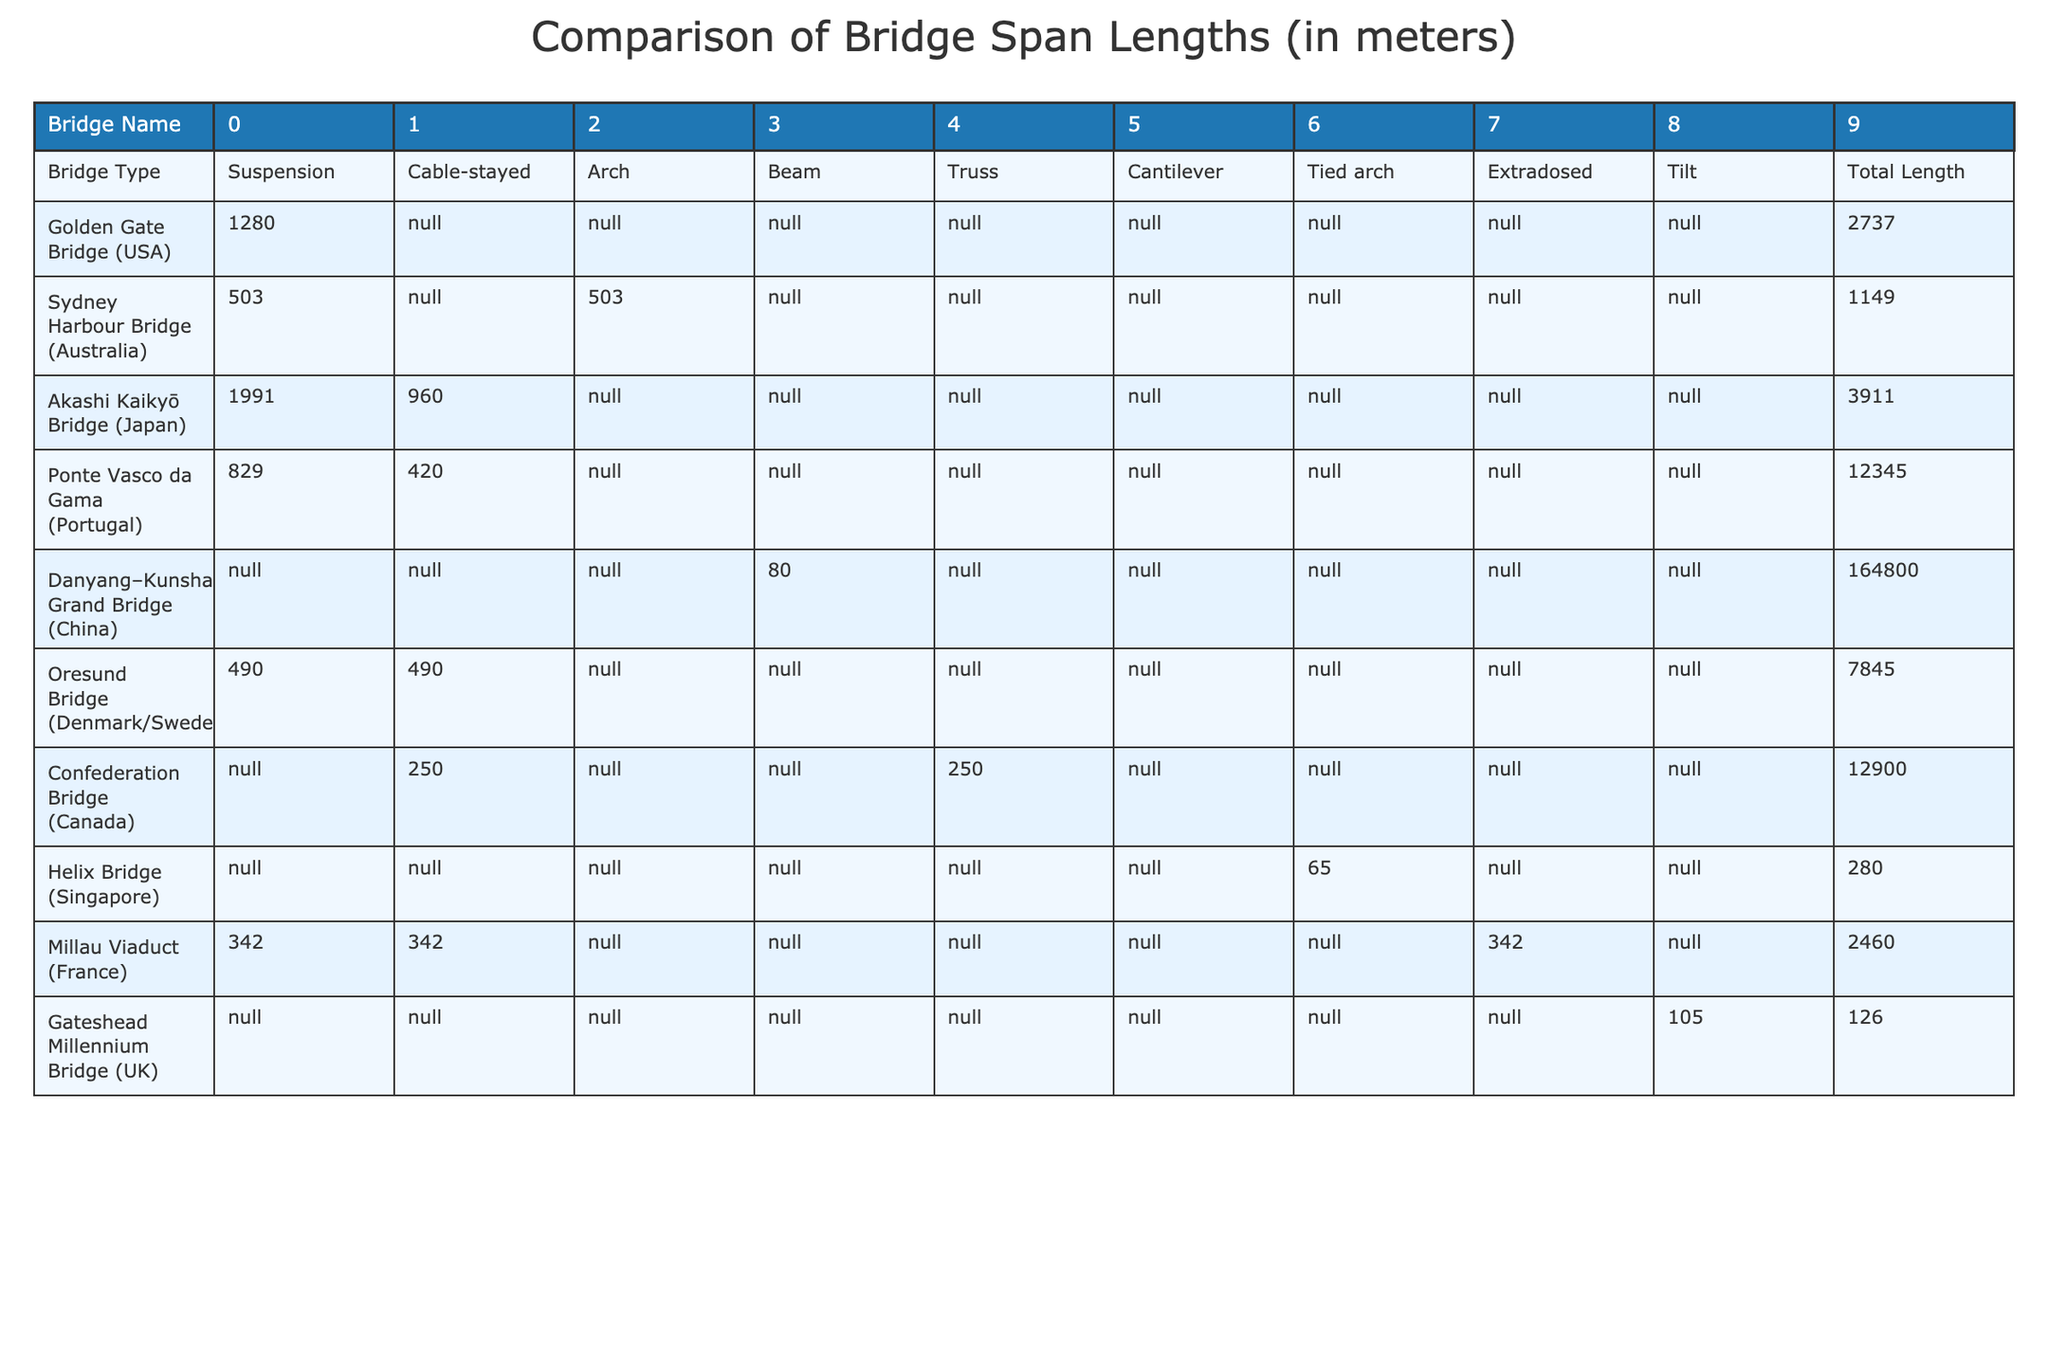What is the span length of the Akashi Kaikyō Bridge? The table shows that the span length of the Akashi Kaikyō Bridge is listed as 1991 meters under the suspension bridge type column.
Answer: 1991 meters Which bridge has the longest total length? The total lengths given are 2737 m (Golden Gate Bridge), 1149 m (Sydney Harbour Bridge), 3911 m (Akashi Kaikyō Bridge), 12345 m (Ponte Vasco da Gama), 164800 m (Danyang–Kunshan Grand Bridge), 7845 m (Oresund Bridge), 12900 m (Confederation Bridge), 280 m (Helix Bridge), 2460 m (Millau Viaduct), and 126 m (Gateshead Millennium Bridge). The longest total length is 164800 m (Danyang–Kunshan Grand Bridge).
Answer: 164800 m How many types of bridges have a span length recorded for the Danyang–Kunshan Grand Bridge? The Danyang–Kunshan Grand Bridge only has a recorded total length of 164800 m and does not have any recorded span length for the other bridge types. Therefore, it has zero recorded span lengths for other types.
Answer: 0 What is the average span length for all suspension bridges listed? The suspension bridges listed are Golden Gate Bridge (1280 m), Akashi Kaikyō Bridge (1991 m), and Oresund Bridge (490 m). Adding these span lengths gives a total of 3861 m, divided by 3 (number of bridges) results in an average of 1287 m.
Answer: 1287 m Is any bridge type noted as having no recorded span lengths? By looking at the bridge type section, it shows that several types (Beam, Cantilever, Tied arch, Extradosed) have "N/A" for all span lengths indicating they have no recorded lengths.
Answer: Yes What is the difference in span length between the highest and lowest recorded lengths for cable-stayed bridges? The cable-stayed bridges listed are the Akashi Kaikyō Bridge (960 m), Ponte Vasco da Gama (420 m), and Oresund Bridge (490 m). The highest span is 960 m, and the lowest is 420 m. Their difference is calculated as 960 m - 420 m = 540 m.
Answer: 540 m Which bridge type has the most varied span lengths recorded? When examining the span lengths for each bridge type, the suspension bridge has three different recorded lengths, while the cable-stayed has three but with less variety. As such, suspension has the most varied lengths recorded.
Answer: Suspension bridge Is the Millau Viaduct categorized as a beam or an arch bridge? According to the table, the Millau Viaduct is listed under two types: it shows a span length for the arch type only. The table does not point to it being a beam bridge.
Answer: Arch bridge 